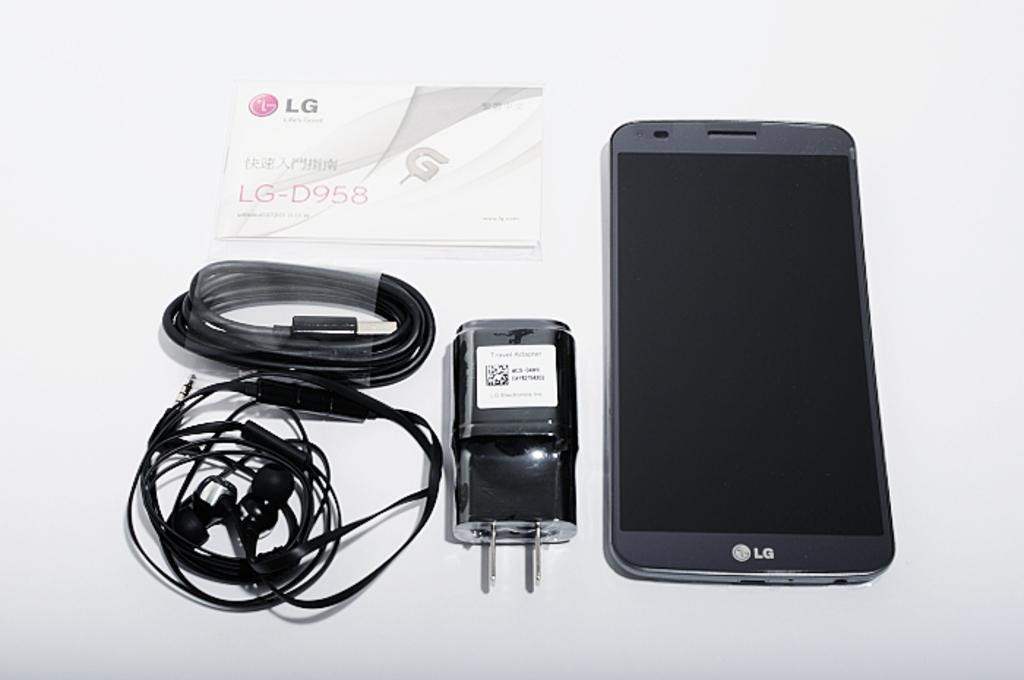<image>
Summarize the visual content of the image. An LG phone lays on a table next to a travel adapter. 